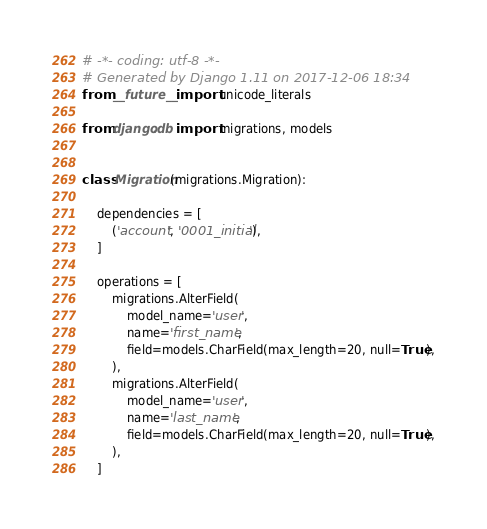Convert code to text. <code><loc_0><loc_0><loc_500><loc_500><_Python_># -*- coding: utf-8 -*-
# Generated by Django 1.11 on 2017-12-06 18:34
from __future__ import unicode_literals

from django.db import migrations, models


class Migration(migrations.Migration):

    dependencies = [
        ('account', '0001_initial'),
    ]

    operations = [
        migrations.AlterField(
            model_name='user',
            name='first_name',
            field=models.CharField(max_length=20, null=True),
        ),
        migrations.AlterField(
            model_name='user',
            name='last_name',
            field=models.CharField(max_length=20, null=True),
        ),
    ]
</code> 